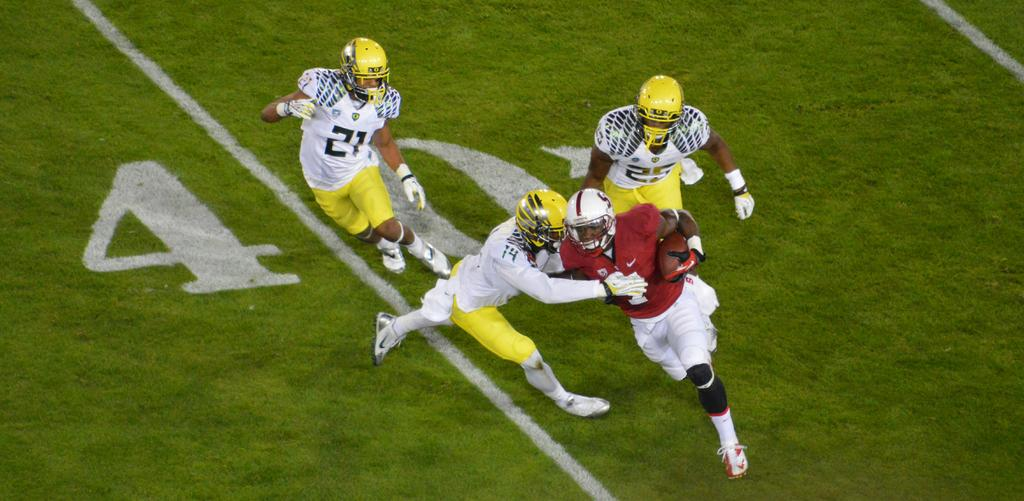What are the people in the image doing? The people in the center of the image are playing a game. What is the surface beneath the people in the image? There is grass at the bottom of the image. What type of yarn is being used in the game in the image? There is no yarn present in the image; the people are playing a game without any yarn. 